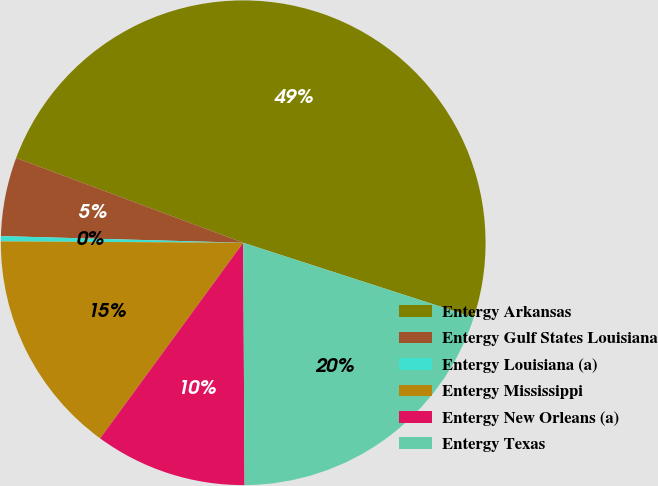<chart> <loc_0><loc_0><loc_500><loc_500><pie_chart><fcel>Entergy Arkansas<fcel>Entergy Gulf States Louisiana<fcel>Entergy Louisiana (a)<fcel>Entergy Mississippi<fcel>Entergy New Orleans (a)<fcel>Entergy Texas<nl><fcel>49.3%<fcel>5.25%<fcel>0.35%<fcel>15.04%<fcel>10.14%<fcel>19.93%<nl></chart> 